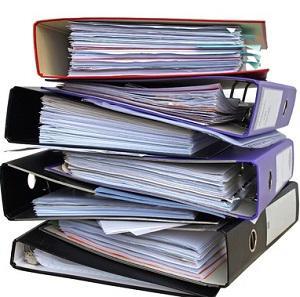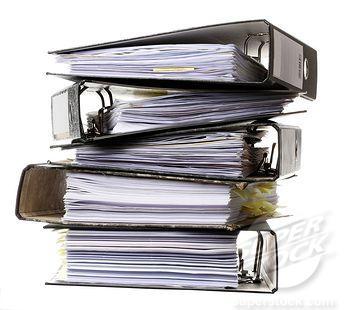The first image is the image on the left, the second image is the image on the right. For the images shown, is this caption "An image contains no more than five binders, which are stacked alternately, front to back." true? Answer yes or no. Yes. The first image is the image on the left, the second image is the image on the right. For the images displayed, is the sentence "In one image, no more than five notebooks filled with paper contents are stacked with ring ends on alternating sides, while a second image shows similar notebooks and contents in a larger stack." factually correct? Answer yes or no. Yes. 